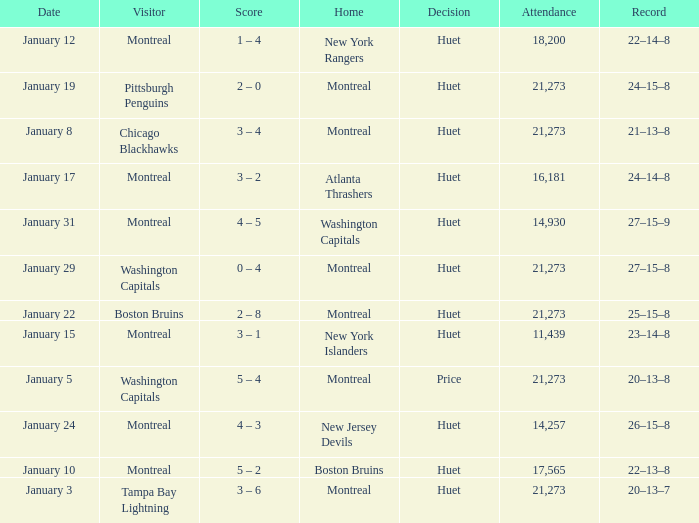What was the result of the game when the boston bruins played as guests? 2 – 8. 